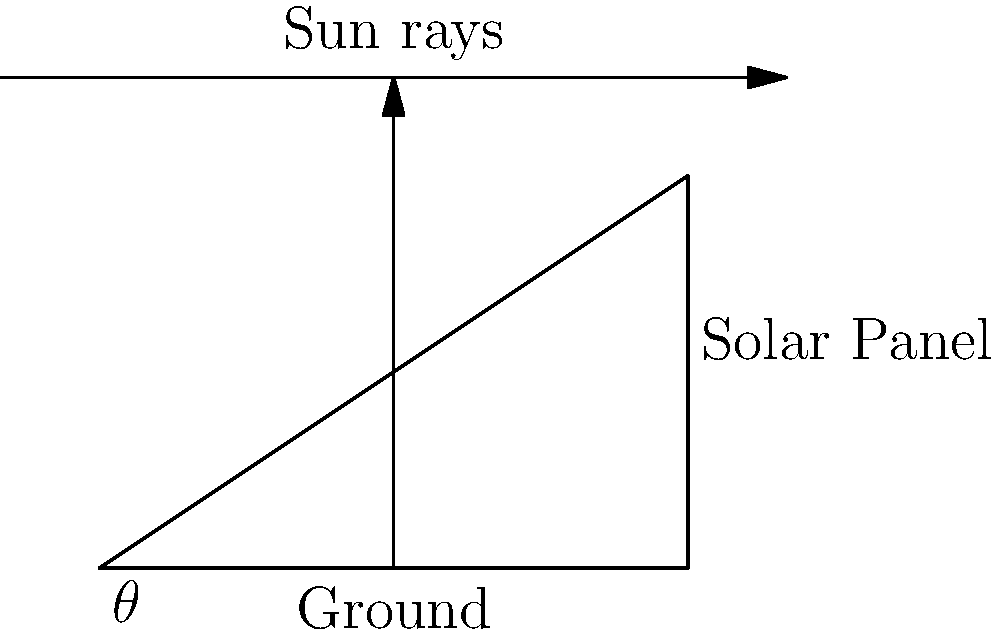As a computer science student developing an open-source platform for academic research, you're working on a module for renewable energy optimization. You need to determine the optimal angle $\theta$ for solar panels to maximize energy absorption. Given that the efficiency of the solar panel is proportional to $\cos(\frac{\pi}{2} - \theta)$, and the area exposed to sunlight is proportional to $\cos(\theta)$, find the angle $\theta$ that maximizes the overall energy collection, which is proportional to the product of these two factors. Let's approach this step-by-step:

1) The overall energy collection is proportional to:
   $$E(\theta) = \cos(\frac{\pi}{2} - \theta) \cdot \cos(\theta)$$

2) To maximize this, we need to find the derivative and set it to zero:
   $$\frac{dE}{d\theta} = \frac{d}{d\theta}[\cos(\frac{\pi}{2} - \theta) \cdot \cos(\theta)] = 0$$

3) Using the product rule and chain rule:
   $$\sin(\frac{\pi}{2} - \theta) \cdot \cos(\theta) - \cos(\frac{\pi}{2} - \theta) \cdot \sin(\theta) = 0$$

4) Simplify using trigonometric identities:
   $$\cos(\theta) \cdot \cos(\theta) - \sin(\theta) \cdot \sin(\theta) = 0$$

5) This simplifies to:
   $$\cos(2\theta) = 0$$

6) Solve for $\theta$:
   $$2\theta = \frac{\pi}{2}$$
   $$\theta = \frac{\pi}{4}$$

7) Convert to degrees:
   $$\theta = 45°$$

8) Verify this is a maximum by checking the second derivative or by observing the function's behavior.
Answer: 45° 